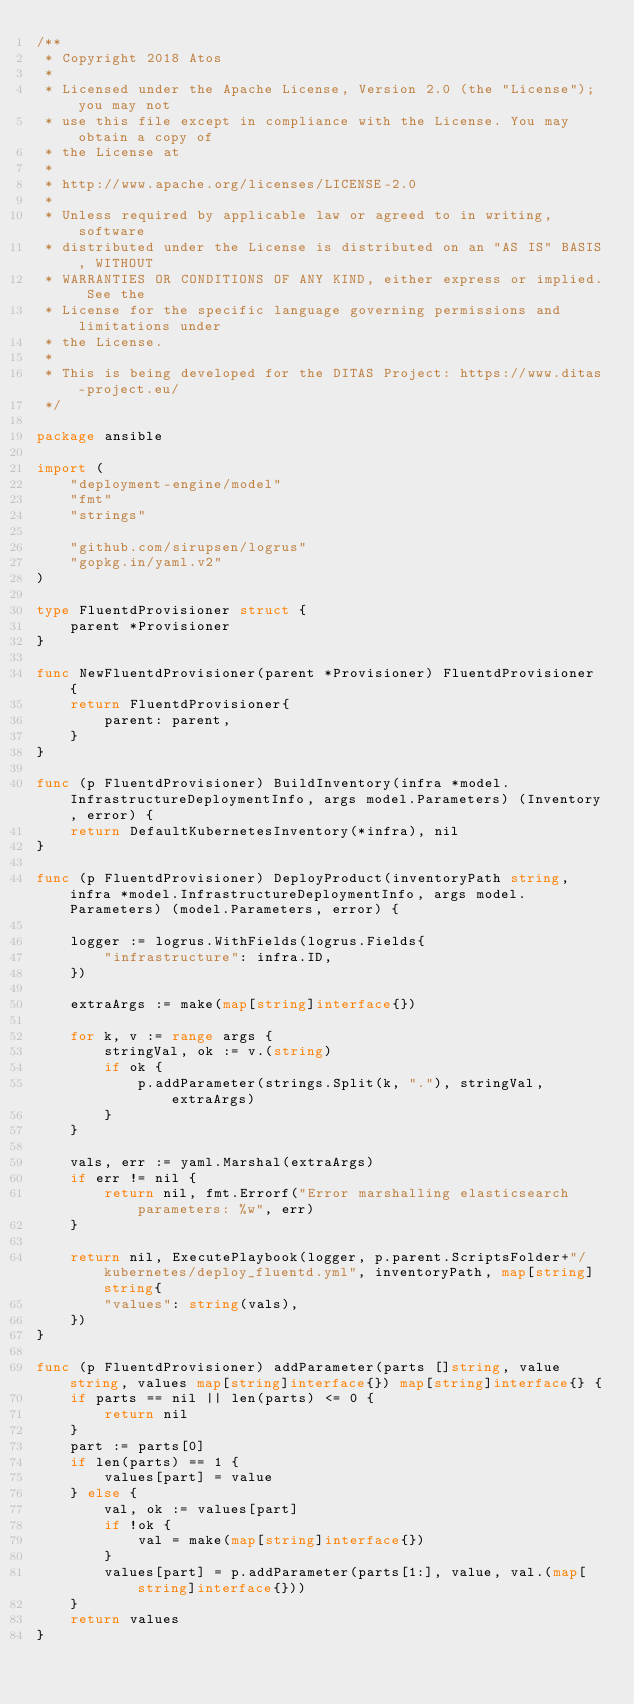Convert code to text. <code><loc_0><loc_0><loc_500><loc_500><_Go_>/**
 * Copyright 2018 Atos
 *
 * Licensed under the Apache License, Version 2.0 (the "License"); you may not
 * use this file except in compliance with the License. You may obtain a copy of
 * the License at
 *
 * http://www.apache.org/licenses/LICENSE-2.0
 *
 * Unless required by applicable law or agreed to in writing, software
 * distributed under the License is distributed on an "AS IS" BASIS, WITHOUT
 * WARRANTIES OR CONDITIONS OF ANY KIND, either express or implied. See the
 * License for the specific language governing permissions and limitations under
 * the License.
 *
 * This is being developed for the DITAS Project: https://www.ditas-project.eu/
 */

package ansible

import (
	"deployment-engine/model"
	"fmt"
	"strings"

	"github.com/sirupsen/logrus"
	"gopkg.in/yaml.v2"
)

type FluentdProvisioner struct {
	parent *Provisioner
}

func NewFluentdProvisioner(parent *Provisioner) FluentdProvisioner {
	return FluentdProvisioner{
		parent: parent,
	}
}

func (p FluentdProvisioner) BuildInventory(infra *model.InfrastructureDeploymentInfo, args model.Parameters) (Inventory, error) {
	return DefaultKubernetesInventory(*infra), nil
}

func (p FluentdProvisioner) DeployProduct(inventoryPath string, infra *model.InfrastructureDeploymentInfo, args model.Parameters) (model.Parameters, error) {

	logger := logrus.WithFields(logrus.Fields{
		"infrastructure": infra.ID,
	})

	extraArgs := make(map[string]interface{})

	for k, v := range args {
		stringVal, ok := v.(string)
		if ok {
			p.addParameter(strings.Split(k, "."), stringVal, extraArgs)
		}
	}

	vals, err := yaml.Marshal(extraArgs)
	if err != nil {
		return nil, fmt.Errorf("Error marshalling elasticsearch parameters: %w", err)
	}

	return nil, ExecutePlaybook(logger, p.parent.ScriptsFolder+"/kubernetes/deploy_fluentd.yml", inventoryPath, map[string]string{
		"values": string(vals),
	})
}

func (p FluentdProvisioner) addParameter(parts []string, value string, values map[string]interface{}) map[string]interface{} {
	if parts == nil || len(parts) <= 0 {
		return nil
	}
	part := parts[0]
	if len(parts) == 1 {
		values[part] = value
	} else {
		val, ok := values[part]
		if !ok {
			val = make(map[string]interface{})
		}
		values[part] = p.addParameter(parts[1:], value, val.(map[string]interface{}))
	}
	return values
}
</code> 